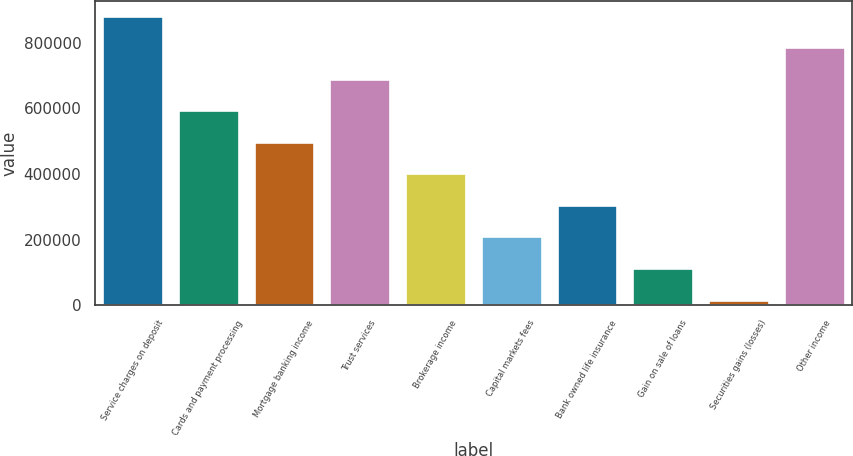Convert chart. <chart><loc_0><loc_0><loc_500><loc_500><bar_chart><fcel>Service charges on deposit<fcel>Cards and payment processing<fcel>Mortgage banking income<fcel>Trust services<fcel>Brokerage income<fcel>Capital markets fees<fcel>Bank owned life insurance<fcel>Gain on sale of loans<fcel>Securities gains (losses)<fcel>Other income<nl><fcel>883016<fcel>594529<fcel>498366<fcel>690692<fcel>402204<fcel>209879<fcel>306042<fcel>113716<fcel>17554<fcel>786854<nl></chart> 